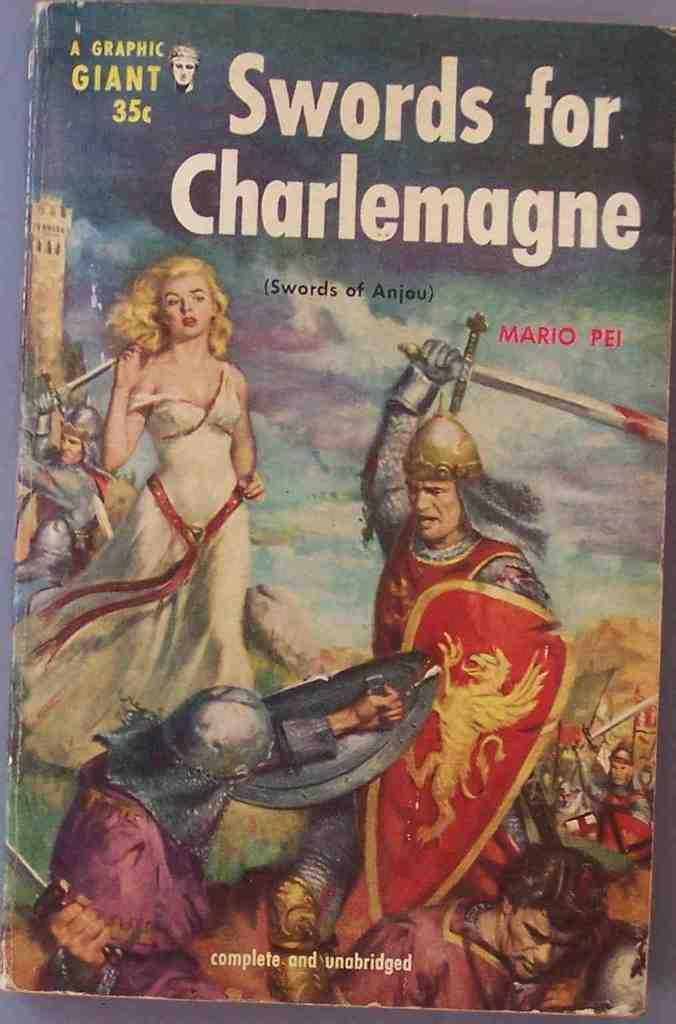<image>
Summarize the visual content of the image. A book titled Swords for Charlemagne costs 35 cents 